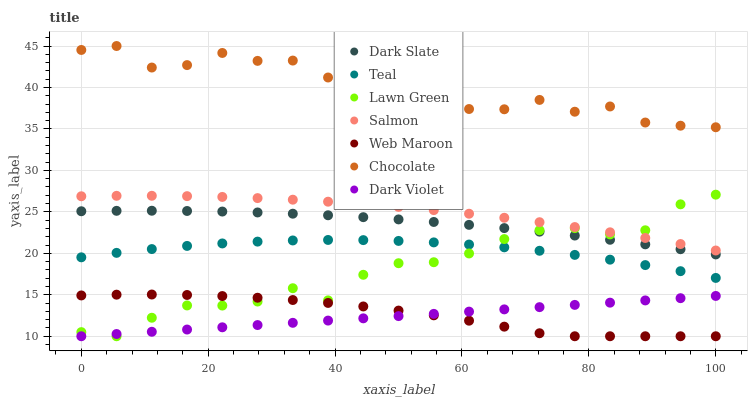Does Dark Violet have the minimum area under the curve?
Answer yes or no. Yes. Does Chocolate have the maximum area under the curve?
Answer yes or no. Yes. Does Salmon have the minimum area under the curve?
Answer yes or no. No. Does Salmon have the maximum area under the curve?
Answer yes or no. No. Is Dark Violet the smoothest?
Answer yes or no. Yes. Is Chocolate the roughest?
Answer yes or no. Yes. Is Salmon the smoothest?
Answer yes or no. No. Is Salmon the roughest?
Answer yes or no. No. Does Lawn Green have the lowest value?
Answer yes or no. Yes. Does Salmon have the lowest value?
Answer yes or no. No. Does Chocolate have the highest value?
Answer yes or no. Yes. Does Salmon have the highest value?
Answer yes or no. No. Is Teal less than Dark Slate?
Answer yes or no. Yes. Is Dark Slate greater than Dark Violet?
Answer yes or no. Yes. Does Dark Slate intersect Lawn Green?
Answer yes or no. Yes. Is Dark Slate less than Lawn Green?
Answer yes or no. No. Is Dark Slate greater than Lawn Green?
Answer yes or no. No. Does Teal intersect Dark Slate?
Answer yes or no. No. 